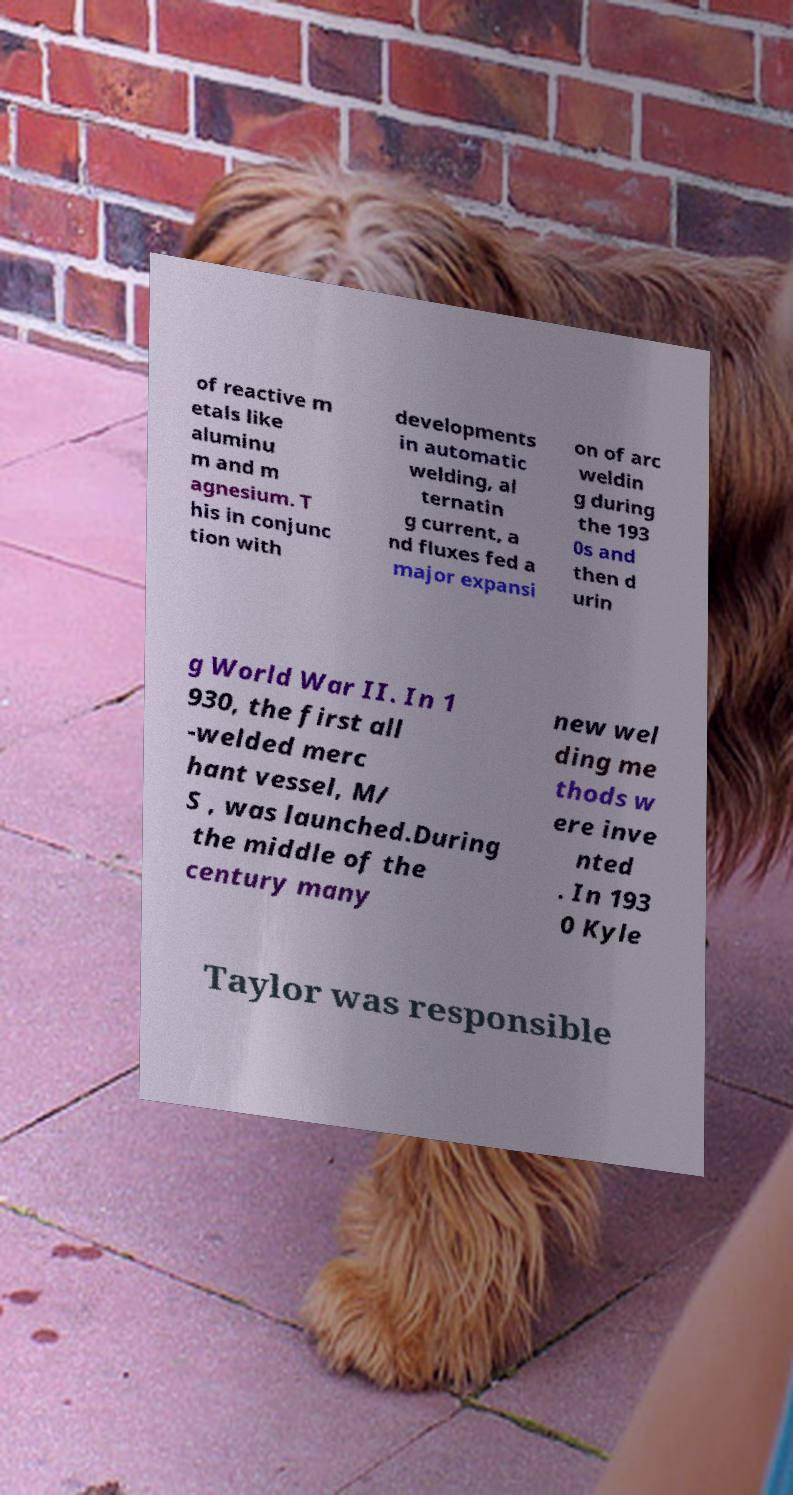I need the written content from this picture converted into text. Can you do that? of reactive m etals like aluminu m and m agnesium. T his in conjunc tion with developments in automatic welding, al ternatin g current, a nd fluxes fed a major expansi on of arc weldin g during the 193 0s and then d urin g World War II. In 1 930, the first all -welded merc hant vessel, M/ S , was launched.During the middle of the century many new wel ding me thods w ere inve nted . In 193 0 Kyle Taylor was responsible 